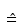<formula> <loc_0><loc_0><loc_500><loc_500>\hat { = }</formula> 